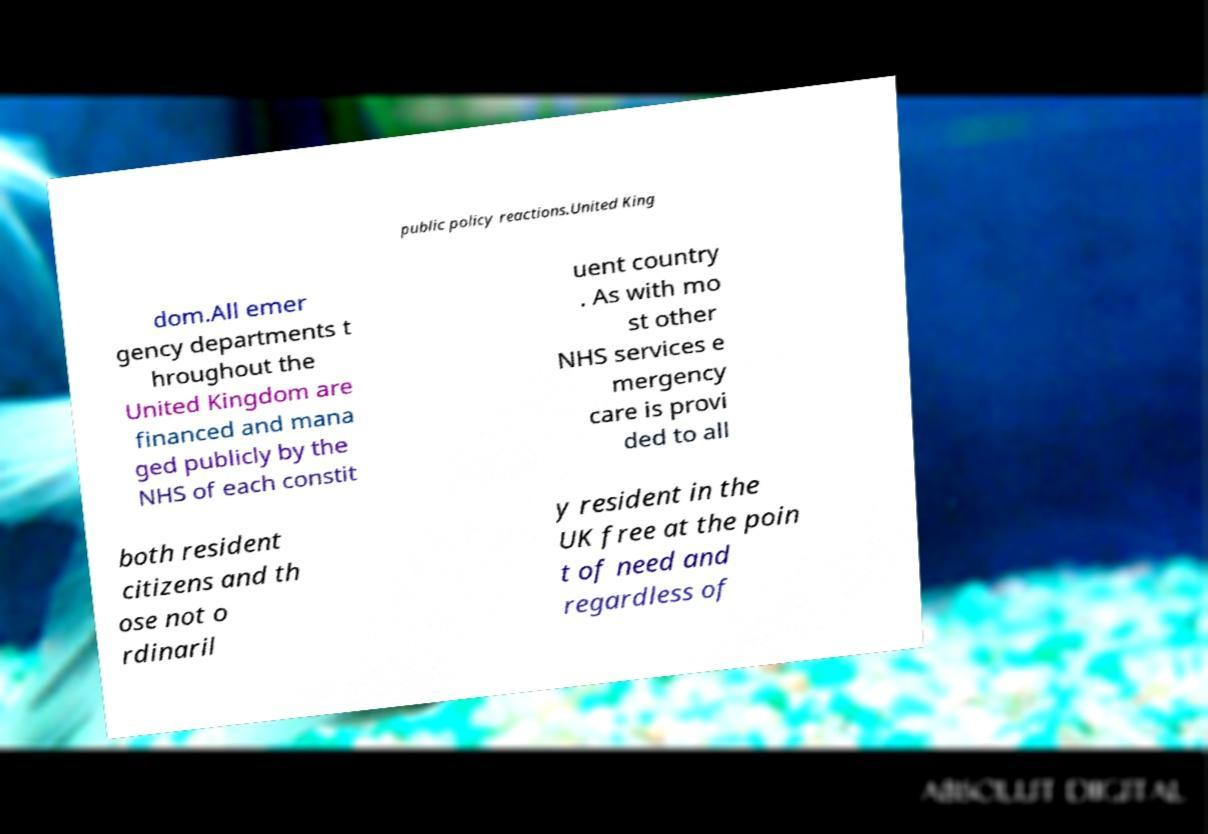Can you accurately transcribe the text from the provided image for me? public policy reactions.United King dom.All emer gency departments t hroughout the United Kingdom are financed and mana ged publicly by the NHS of each constit uent country . As with mo st other NHS services e mergency care is provi ded to all both resident citizens and th ose not o rdinaril y resident in the UK free at the poin t of need and regardless of 